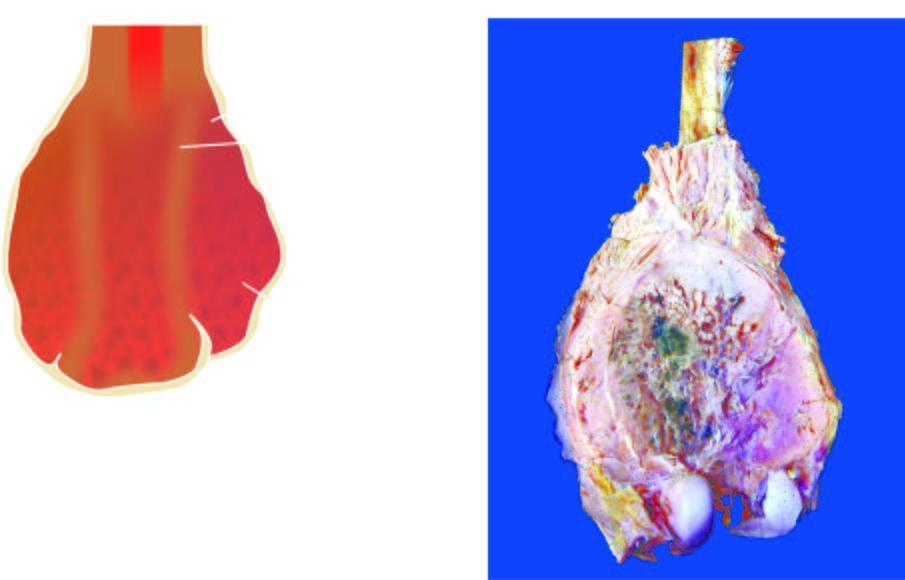does 'triple response ' show a bulky expanded tumour in the region of metaphysis sparing the epiphyseal cartilage?
Answer the question using a single word or phrase. No 